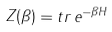<formula> <loc_0><loc_0><loc_500><loc_500>Z ( \beta ) = t r \, e ^ { - \beta H }</formula> 